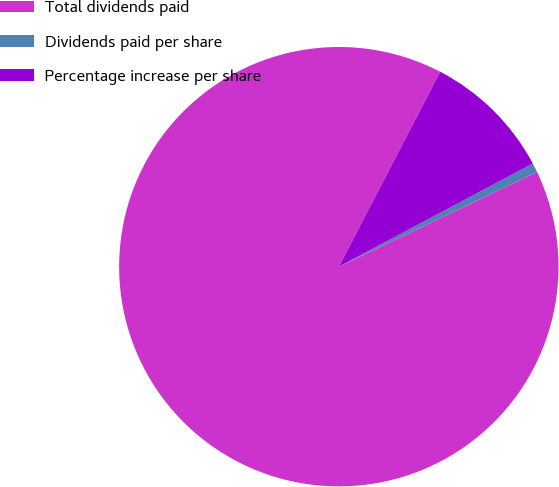Convert chart. <chart><loc_0><loc_0><loc_500><loc_500><pie_chart><fcel>Total dividends paid<fcel>Dividends paid per share<fcel>Percentage increase per share<nl><fcel>89.73%<fcel>0.68%<fcel>9.59%<nl></chart> 